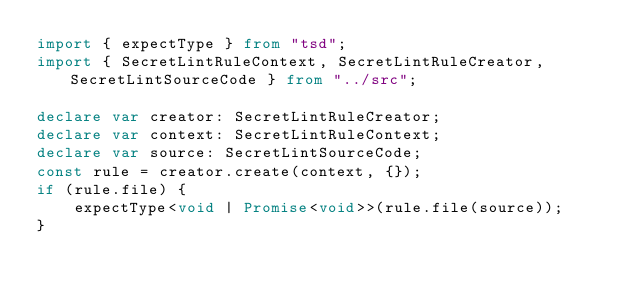<code> <loc_0><loc_0><loc_500><loc_500><_TypeScript_>import { expectType } from "tsd";
import { SecretLintRuleContext, SecretLintRuleCreator, SecretLintSourceCode } from "../src";

declare var creator: SecretLintRuleCreator;
declare var context: SecretLintRuleContext;
declare var source: SecretLintSourceCode;
const rule = creator.create(context, {});
if (rule.file) {
    expectType<void | Promise<void>>(rule.file(source));
}
</code> 